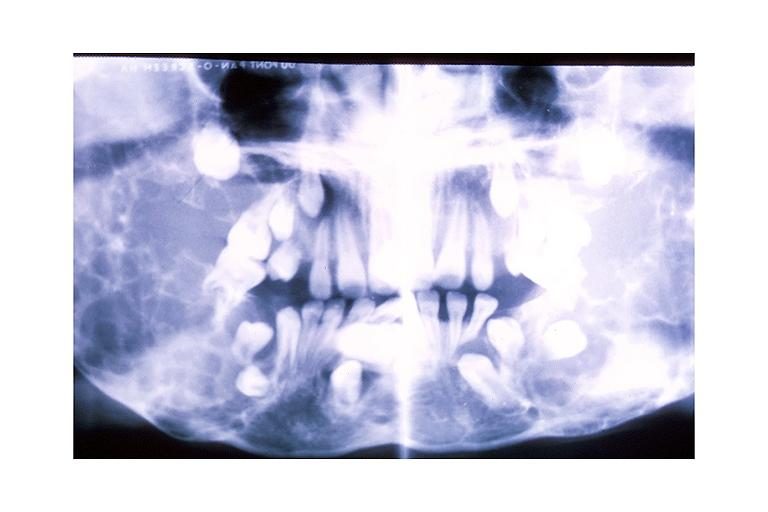does this image show cherubism?
Answer the question using a single word or phrase. Yes 